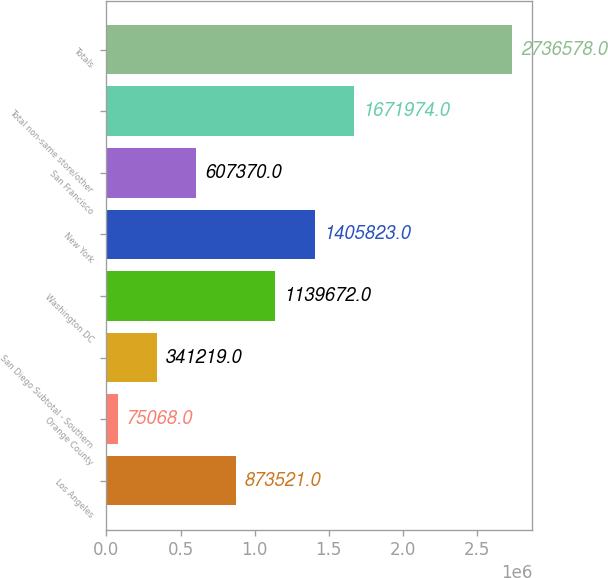Convert chart. <chart><loc_0><loc_0><loc_500><loc_500><bar_chart><fcel>Los Angeles<fcel>Orange County<fcel>San Diego Subtotal - Southern<fcel>Washington DC<fcel>New York<fcel>San Francisco<fcel>Total non-same store/other<fcel>Totals<nl><fcel>873521<fcel>75068<fcel>341219<fcel>1.13967e+06<fcel>1.40582e+06<fcel>607370<fcel>1.67197e+06<fcel>2.73658e+06<nl></chart> 